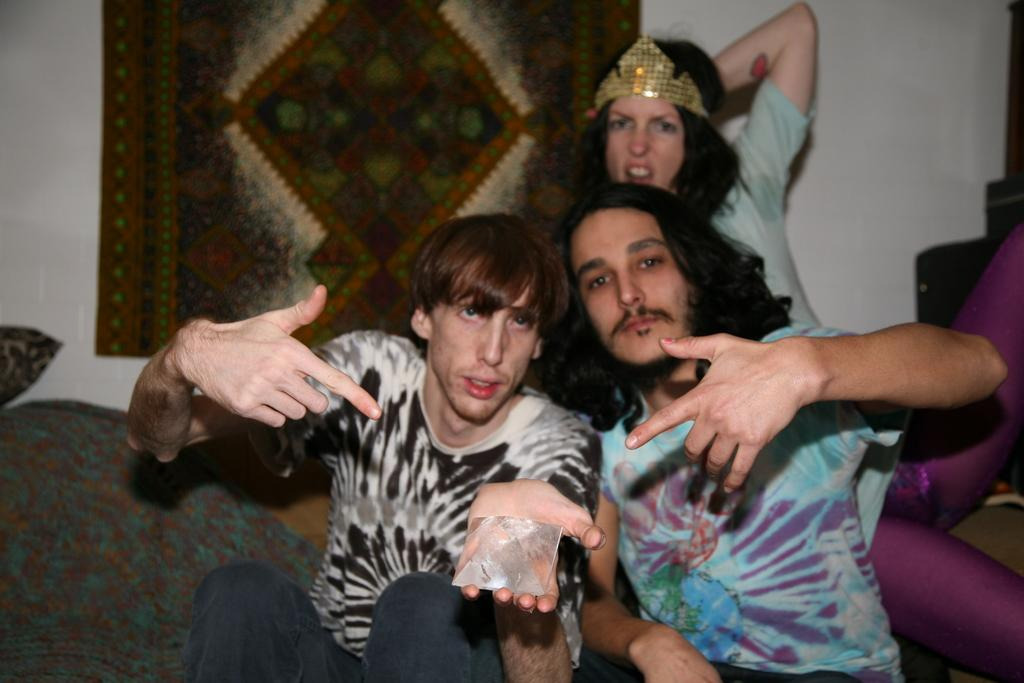How many people are in the image? There are three persons in the image. What are the persons doing in the image? The persons are posing for a camera. What objects can be seen in the image besides the people? There are pillows in the image. What can be seen in the background of the image? There is a wall and cloth in the background of the image. What type of furniture is visible in the image? There is no furniture present in the image. What color is the hair of the person on the left in the image? There is no person on the left in the image, and we cannot determine the color of anyone's hair from the provided facts. 